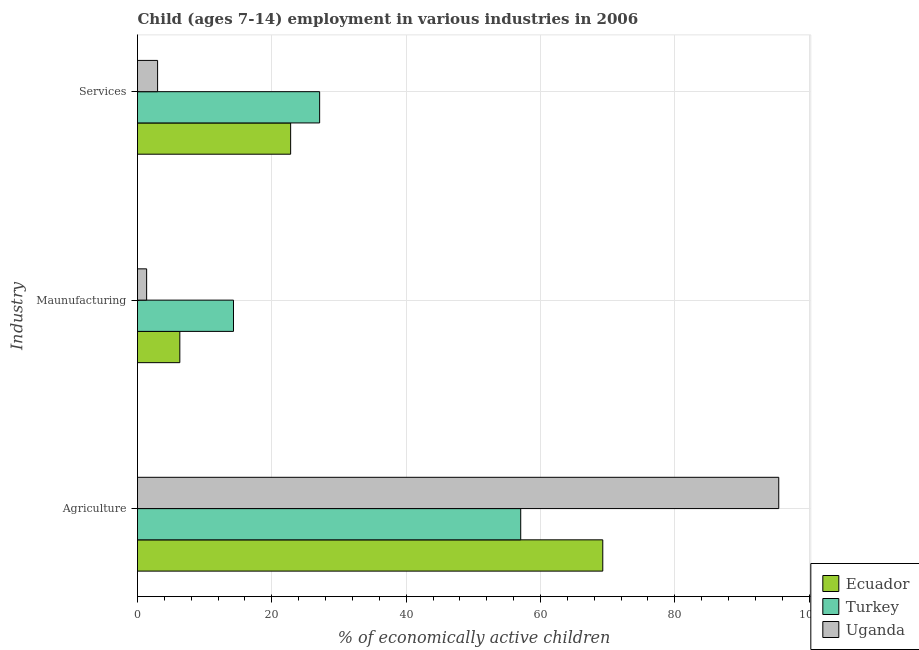How many different coloured bars are there?
Your answer should be compact. 3. How many groups of bars are there?
Provide a short and direct response. 3. Are the number of bars on each tick of the Y-axis equal?
Your response must be concise. Yes. What is the label of the 3rd group of bars from the top?
Offer a terse response. Agriculture. What is the percentage of economically active children in agriculture in Ecuador?
Offer a very short reply. 69.28. Across all countries, what is the maximum percentage of economically active children in services?
Provide a succinct answer. 27.12. Across all countries, what is the minimum percentage of economically active children in manufacturing?
Provide a short and direct response. 1.36. In which country was the percentage of economically active children in manufacturing minimum?
Give a very brief answer. Uganda. What is the total percentage of economically active children in agriculture in the graph?
Your response must be concise. 221.82. What is the difference between the percentage of economically active children in manufacturing in Turkey and that in Uganda?
Offer a terse response. 12.93. What is the difference between the percentage of economically active children in agriculture in Turkey and the percentage of economically active children in manufacturing in Uganda?
Keep it short and to the point. 55.7. What is the average percentage of economically active children in services per country?
Ensure brevity in your answer.  17.64. What is the difference between the percentage of economically active children in agriculture and percentage of economically active children in services in Turkey?
Ensure brevity in your answer.  29.94. In how many countries, is the percentage of economically active children in services greater than 60 %?
Offer a very short reply. 0. What is the ratio of the percentage of economically active children in agriculture in Ecuador to that in Turkey?
Offer a terse response. 1.21. Is the difference between the percentage of economically active children in services in Turkey and Uganda greater than the difference between the percentage of economically active children in manufacturing in Turkey and Uganda?
Ensure brevity in your answer.  Yes. What is the difference between the highest and the second highest percentage of economically active children in manufacturing?
Your answer should be compact. 7.99. What is the difference between the highest and the lowest percentage of economically active children in services?
Make the answer very short. 24.13. Is the sum of the percentage of economically active children in agriculture in Turkey and Ecuador greater than the maximum percentage of economically active children in services across all countries?
Make the answer very short. Yes. What does the 1st bar from the top in Maunufacturing represents?
Your response must be concise. Uganda. What does the 1st bar from the bottom in Maunufacturing represents?
Your answer should be compact. Ecuador. How many countries are there in the graph?
Make the answer very short. 3. Are the values on the major ticks of X-axis written in scientific E-notation?
Give a very brief answer. No. Does the graph contain grids?
Your response must be concise. Yes. What is the title of the graph?
Ensure brevity in your answer.  Child (ages 7-14) employment in various industries in 2006. Does "Jordan" appear as one of the legend labels in the graph?
Provide a short and direct response. No. What is the label or title of the X-axis?
Provide a short and direct response. % of economically active children. What is the label or title of the Y-axis?
Ensure brevity in your answer.  Industry. What is the % of economically active children of Ecuador in Agriculture?
Give a very brief answer. 69.28. What is the % of economically active children in Turkey in Agriculture?
Keep it short and to the point. 57.06. What is the % of economically active children in Uganda in Agriculture?
Make the answer very short. 95.48. What is the % of economically active children of Ecuador in Maunufacturing?
Your answer should be very brief. 6.3. What is the % of economically active children in Turkey in Maunufacturing?
Your answer should be very brief. 14.29. What is the % of economically active children in Uganda in Maunufacturing?
Your response must be concise. 1.36. What is the % of economically active children of Ecuador in Services?
Give a very brief answer. 22.8. What is the % of economically active children of Turkey in Services?
Your answer should be compact. 27.12. What is the % of economically active children of Uganda in Services?
Give a very brief answer. 2.99. Across all Industry, what is the maximum % of economically active children of Ecuador?
Offer a terse response. 69.28. Across all Industry, what is the maximum % of economically active children in Turkey?
Your response must be concise. 57.06. Across all Industry, what is the maximum % of economically active children of Uganda?
Your answer should be compact. 95.48. Across all Industry, what is the minimum % of economically active children of Ecuador?
Keep it short and to the point. 6.3. Across all Industry, what is the minimum % of economically active children of Turkey?
Provide a succinct answer. 14.29. Across all Industry, what is the minimum % of economically active children of Uganda?
Provide a short and direct response. 1.36. What is the total % of economically active children of Ecuador in the graph?
Provide a short and direct response. 98.38. What is the total % of economically active children of Turkey in the graph?
Your answer should be compact. 98.47. What is the total % of economically active children of Uganda in the graph?
Make the answer very short. 99.83. What is the difference between the % of economically active children of Ecuador in Agriculture and that in Maunufacturing?
Offer a very short reply. 62.98. What is the difference between the % of economically active children of Turkey in Agriculture and that in Maunufacturing?
Keep it short and to the point. 42.77. What is the difference between the % of economically active children in Uganda in Agriculture and that in Maunufacturing?
Ensure brevity in your answer.  94.12. What is the difference between the % of economically active children of Ecuador in Agriculture and that in Services?
Ensure brevity in your answer.  46.48. What is the difference between the % of economically active children in Turkey in Agriculture and that in Services?
Your answer should be compact. 29.94. What is the difference between the % of economically active children in Uganda in Agriculture and that in Services?
Provide a succinct answer. 92.49. What is the difference between the % of economically active children of Ecuador in Maunufacturing and that in Services?
Provide a succinct answer. -16.5. What is the difference between the % of economically active children in Turkey in Maunufacturing and that in Services?
Give a very brief answer. -12.83. What is the difference between the % of economically active children of Uganda in Maunufacturing and that in Services?
Your response must be concise. -1.63. What is the difference between the % of economically active children of Ecuador in Agriculture and the % of economically active children of Turkey in Maunufacturing?
Make the answer very short. 54.99. What is the difference between the % of economically active children in Ecuador in Agriculture and the % of economically active children in Uganda in Maunufacturing?
Provide a short and direct response. 67.92. What is the difference between the % of economically active children of Turkey in Agriculture and the % of economically active children of Uganda in Maunufacturing?
Make the answer very short. 55.7. What is the difference between the % of economically active children in Ecuador in Agriculture and the % of economically active children in Turkey in Services?
Provide a short and direct response. 42.16. What is the difference between the % of economically active children in Ecuador in Agriculture and the % of economically active children in Uganda in Services?
Offer a very short reply. 66.29. What is the difference between the % of economically active children in Turkey in Agriculture and the % of economically active children in Uganda in Services?
Your response must be concise. 54.07. What is the difference between the % of economically active children of Ecuador in Maunufacturing and the % of economically active children of Turkey in Services?
Offer a very short reply. -20.82. What is the difference between the % of economically active children of Ecuador in Maunufacturing and the % of economically active children of Uganda in Services?
Your answer should be compact. 3.31. What is the difference between the % of economically active children of Turkey in Maunufacturing and the % of economically active children of Uganda in Services?
Give a very brief answer. 11.3. What is the average % of economically active children in Ecuador per Industry?
Keep it short and to the point. 32.79. What is the average % of economically active children of Turkey per Industry?
Offer a terse response. 32.82. What is the average % of economically active children of Uganda per Industry?
Offer a terse response. 33.28. What is the difference between the % of economically active children of Ecuador and % of economically active children of Turkey in Agriculture?
Offer a very short reply. 12.22. What is the difference between the % of economically active children of Ecuador and % of economically active children of Uganda in Agriculture?
Your answer should be very brief. -26.2. What is the difference between the % of economically active children of Turkey and % of economically active children of Uganda in Agriculture?
Your answer should be compact. -38.42. What is the difference between the % of economically active children of Ecuador and % of economically active children of Turkey in Maunufacturing?
Give a very brief answer. -7.99. What is the difference between the % of economically active children of Ecuador and % of economically active children of Uganda in Maunufacturing?
Make the answer very short. 4.94. What is the difference between the % of economically active children of Turkey and % of economically active children of Uganda in Maunufacturing?
Keep it short and to the point. 12.93. What is the difference between the % of economically active children of Ecuador and % of economically active children of Turkey in Services?
Ensure brevity in your answer.  -4.32. What is the difference between the % of economically active children of Ecuador and % of economically active children of Uganda in Services?
Give a very brief answer. 19.81. What is the difference between the % of economically active children of Turkey and % of economically active children of Uganda in Services?
Offer a terse response. 24.13. What is the ratio of the % of economically active children of Ecuador in Agriculture to that in Maunufacturing?
Your answer should be very brief. 11. What is the ratio of the % of economically active children of Turkey in Agriculture to that in Maunufacturing?
Keep it short and to the point. 3.99. What is the ratio of the % of economically active children in Uganda in Agriculture to that in Maunufacturing?
Make the answer very short. 70.21. What is the ratio of the % of economically active children in Ecuador in Agriculture to that in Services?
Give a very brief answer. 3.04. What is the ratio of the % of economically active children of Turkey in Agriculture to that in Services?
Provide a short and direct response. 2.1. What is the ratio of the % of economically active children in Uganda in Agriculture to that in Services?
Your response must be concise. 31.93. What is the ratio of the % of economically active children of Ecuador in Maunufacturing to that in Services?
Keep it short and to the point. 0.28. What is the ratio of the % of economically active children in Turkey in Maunufacturing to that in Services?
Your response must be concise. 0.53. What is the ratio of the % of economically active children in Uganda in Maunufacturing to that in Services?
Keep it short and to the point. 0.45. What is the difference between the highest and the second highest % of economically active children of Ecuador?
Offer a terse response. 46.48. What is the difference between the highest and the second highest % of economically active children of Turkey?
Keep it short and to the point. 29.94. What is the difference between the highest and the second highest % of economically active children of Uganda?
Make the answer very short. 92.49. What is the difference between the highest and the lowest % of economically active children of Ecuador?
Offer a very short reply. 62.98. What is the difference between the highest and the lowest % of economically active children in Turkey?
Offer a terse response. 42.77. What is the difference between the highest and the lowest % of economically active children of Uganda?
Keep it short and to the point. 94.12. 